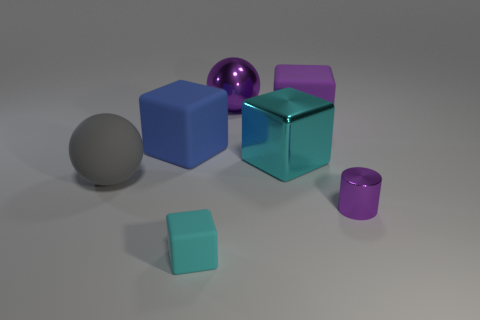Subtract all blue cubes. How many cubes are left? 3 Subtract all shiny blocks. How many blocks are left? 3 Subtract all red cubes. Subtract all gray cylinders. How many cubes are left? 4 Add 1 purple cylinders. How many objects exist? 8 Subtract all cylinders. How many objects are left? 6 Add 6 small purple cubes. How many small purple cubes exist? 6 Subtract 0 yellow blocks. How many objects are left? 7 Subtract all tiny matte spheres. Subtract all cyan matte cubes. How many objects are left? 6 Add 6 small things. How many small things are left? 8 